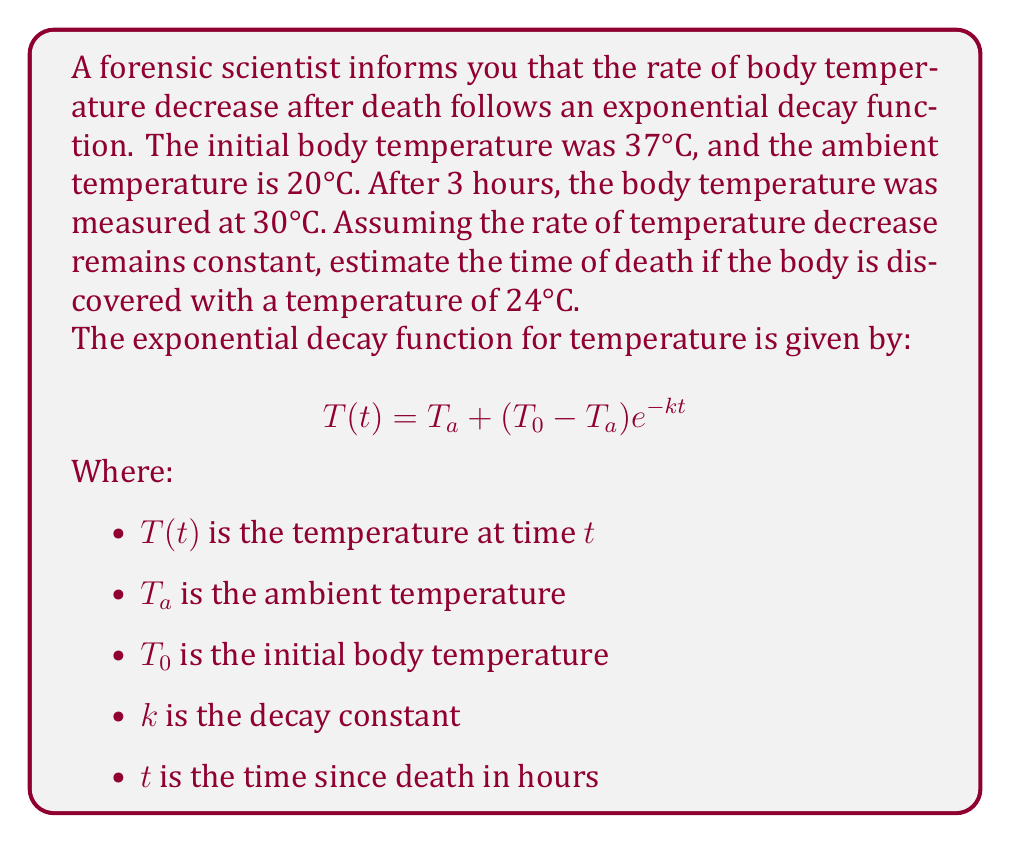Can you answer this question? To solve this problem, we'll follow these steps:

1. Determine the decay constant $k$ using the given information.
2. Use the decay constant to estimate the time of death.

Step 1: Determining the decay constant $k$

We know that after 3 hours, the body temperature was 30°C. Let's use this information in the exponential decay function:

$$30 = 20 + (37 - 20)e^{-k(3)}$$

Simplify:
$$10 = 17e^{-3k}$$

Divide both sides by 17:
$$\frac{10}{17} = e^{-3k}$$

Take the natural log of both sides:
$$\ln(\frac{10}{17}) = -3k$$

Solve for $k$:
$$k = -\frac{1}{3}\ln(\frac{10}{17}) \approx 0.1872$$

Step 2: Estimating the time of death

Now that we have $k$, we can use the exponential decay function to find $t$ when the temperature is 24°C:

$$24 = 20 + (37 - 20)e^{-0.1872t}$$

Simplify:
$$4 = 17e^{-0.1872t}$$

Divide both sides by 17:
$$\frac{4}{17} = e^{-0.1872t}$$

Take the natural log of both sides:
$$\ln(\frac{4}{17}) = -0.1872t$$

Solve for $t$:
$$t = -\frac{1}{0.1872}\ln(\frac{4}{17}) \approx 8.15$$

Therefore, the estimated time of death is approximately 8.15 hours before the body was discovered.
Answer: The estimated time of death is 8.15 hours before the body was discovered. 